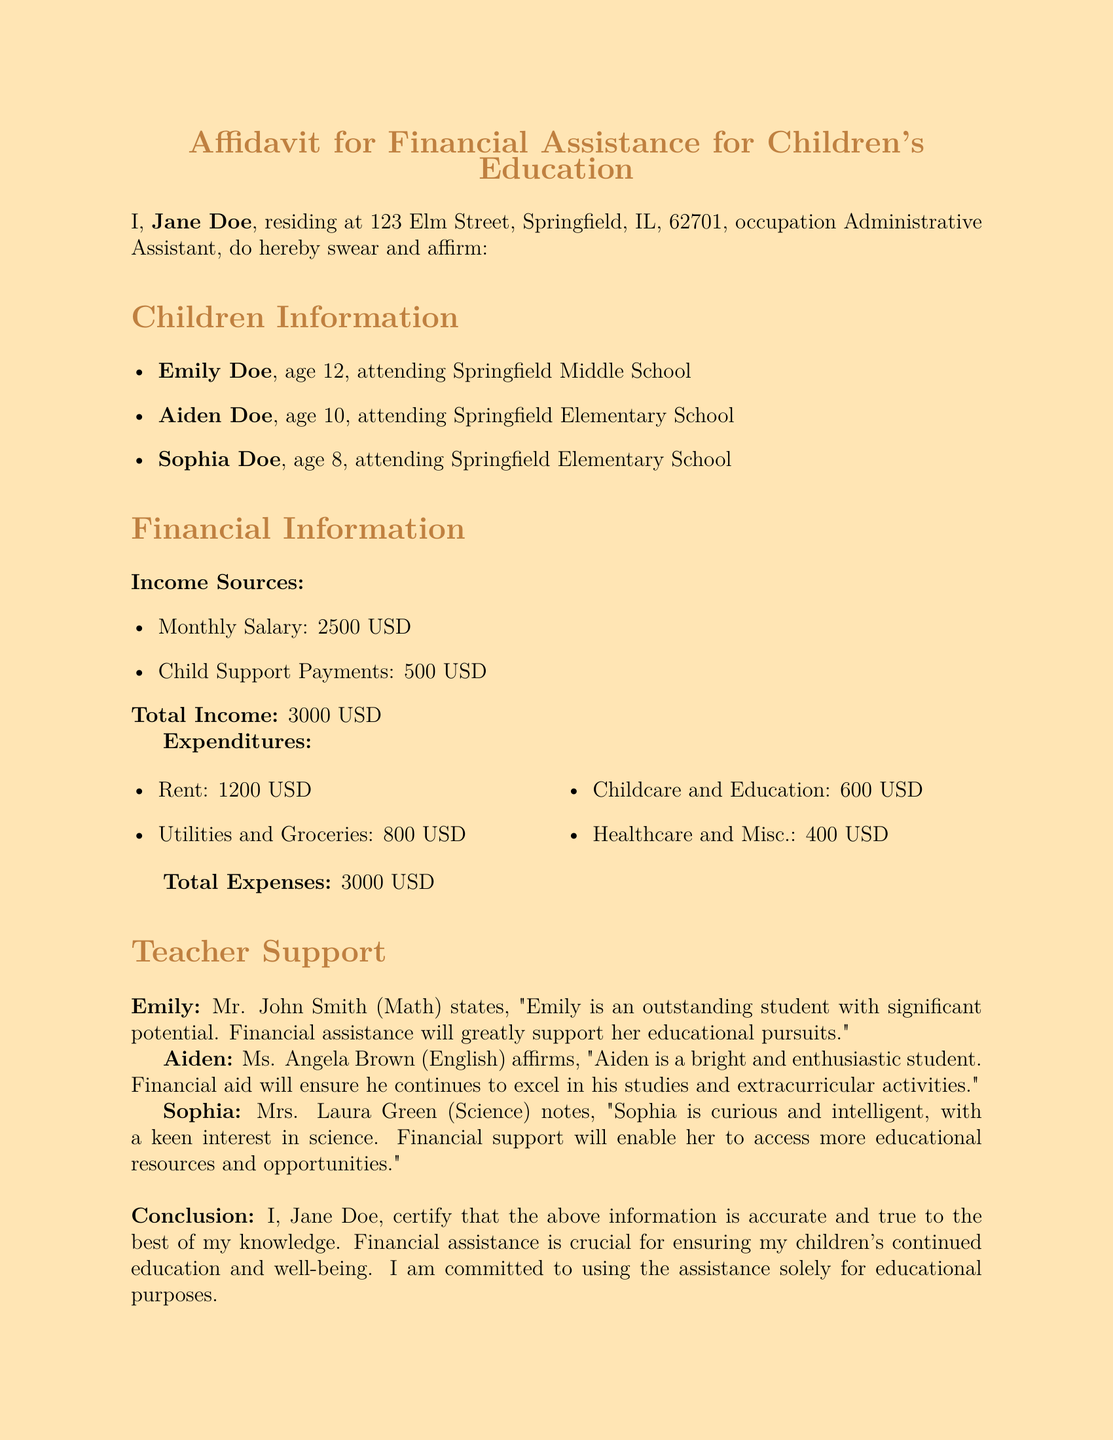What is the name of the applicant? The applicant's name is stated at the beginning of the document as Jane Doe.
Answer: Jane Doe How many children does Jane Doe have? The document lists the names and ages of three children, indicating that Jane Doe has three children.
Answer: Three What is Emily's age? The document specifically mentions that Emily Doe is 12 years old.
Answer: 12 What is the total income reported? The total income is summarized in the Financial Information section, where it amounts to 3000 USD.
Answer: 3000 USD What is listed as a source of income? The document includes both a monthly salary and child support payments as income sources.
Answer: Monthly Salary and Child Support Payments Who is Aiden's English teacher? The document names Ms. Angela Brown as Aiden's English teacher providing a supportive statement.
Answer: Ms. Angela Brown What is the total expense mentioned? The document outlines that the total expenses equal 3000 USD.
Answer: 3000 USD What does Mr. John Smith say about Emily? Mr. John Smith states that Emily is an outstanding student with significant potential.
Answer: Outstanding student with significant potential What is the purpose of requesting financial assistance? The conclusion of the document clearly states that the purpose is to ensure the children's continued education and well-being.
Answer: Children's continued education and well-being 